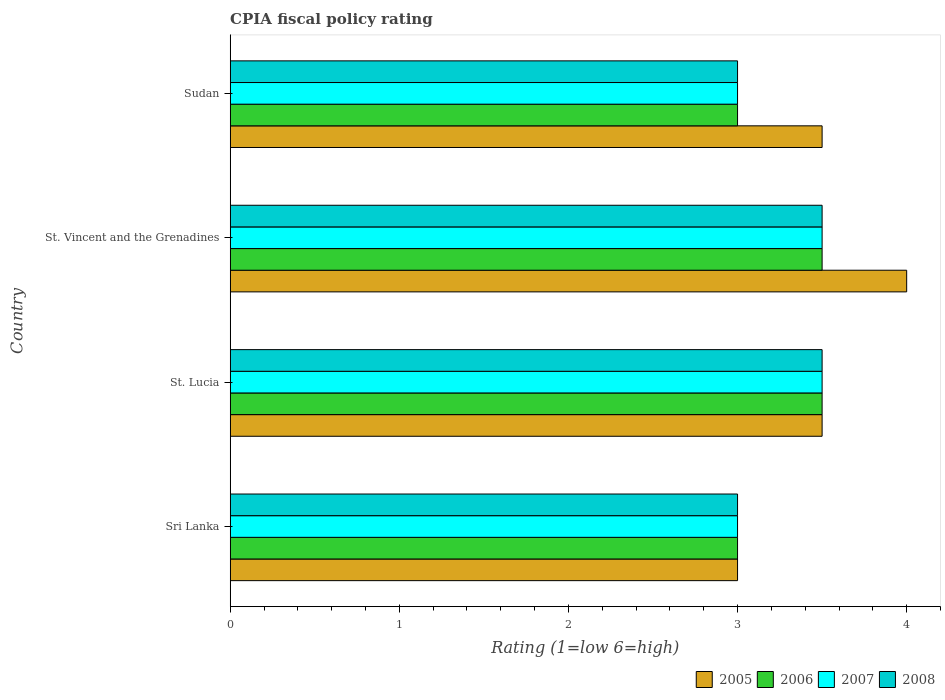How many different coloured bars are there?
Provide a short and direct response. 4. How many groups of bars are there?
Ensure brevity in your answer.  4. Are the number of bars on each tick of the Y-axis equal?
Make the answer very short. Yes. How many bars are there on the 4th tick from the bottom?
Make the answer very short. 4. What is the label of the 3rd group of bars from the top?
Provide a short and direct response. St. Lucia. In how many cases, is the number of bars for a given country not equal to the number of legend labels?
Give a very brief answer. 0. Across all countries, what is the minimum CPIA rating in 2005?
Your answer should be very brief. 3. In which country was the CPIA rating in 2006 maximum?
Provide a succinct answer. St. Lucia. In which country was the CPIA rating in 2007 minimum?
Keep it short and to the point. Sri Lanka. What is the difference between the CPIA rating in 2008 in St. Lucia and the CPIA rating in 2006 in Sri Lanka?
Provide a succinct answer. 0.5. What is the average CPIA rating in 2007 per country?
Keep it short and to the point. 3.25. What is the difference between the CPIA rating in 2007 and CPIA rating in 2006 in Sri Lanka?
Your answer should be compact. 0. In how many countries, is the CPIA rating in 2005 greater than 1.4 ?
Your response must be concise. 4. What is the ratio of the CPIA rating in 2006 in St. Lucia to that in Sudan?
Offer a very short reply. 1.17. Is the CPIA rating in 2006 in St. Vincent and the Grenadines less than that in Sudan?
Provide a succinct answer. No. Is the difference between the CPIA rating in 2007 in Sri Lanka and Sudan greater than the difference between the CPIA rating in 2006 in Sri Lanka and Sudan?
Make the answer very short. No. What is the difference between the highest and the second highest CPIA rating in 2006?
Keep it short and to the point. 0. What does the 2nd bar from the top in Sri Lanka represents?
Your answer should be compact. 2007. What does the 1st bar from the bottom in St. Vincent and the Grenadines represents?
Provide a short and direct response. 2005. Is it the case that in every country, the sum of the CPIA rating in 2007 and CPIA rating in 2006 is greater than the CPIA rating in 2005?
Offer a terse response. Yes. How many bars are there?
Give a very brief answer. 16. Are all the bars in the graph horizontal?
Provide a succinct answer. Yes. What is the difference between two consecutive major ticks on the X-axis?
Provide a succinct answer. 1. Does the graph contain any zero values?
Provide a short and direct response. No. How many legend labels are there?
Make the answer very short. 4. How are the legend labels stacked?
Give a very brief answer. Horizontal. What is the title of the graph?
Give a very brief answer. CPIA fiscal policy rating. Does "1998" appear as one of the legend labels in the graph?
Provide a succinct answer. No. What is the Rating (1=low 6=high) in 2007 in Sri Lanka?
Provide a succinct answer. 3. What is the Rating (1=low 6=high) of 2008 in Sri Lanka?
Offer a very short reply. 3. What is the Rating (1=low 6=high) in 2005 in St. Lucia?
Provide a succinct answer. 3.5. What is the Rating (1=low 6=high) in 2006 in St. Lucia?
Your answer should be very brief. 3.5. What is the Rating (1=low 6=high) of 2008 in St. Lucia?
Ensure brevity in your answer.  3.5. What is the Rating (1=low 6=high) in 2005 in St. Vincent and the Grenadines?
Make the answer very short. 4. What is the Rating (1=low 6=high) in 2006 in St. Vincent and the Grenadines?
Offer a terse response. 3.5. What is the Rating (1=low 6=high) of 2005 in Sudan?
Offer a very short reply. 3.5. What is the Rating (1=low 6=high) of 2006 in Sudan?
Offer a very short reply. 3. What is the Rating (1=low 6=high) in 2007 in Sudan?
Your answer should be very brief. 3. Across all countries, what is the maximum Rating (1=low 6=high) in 2006?
Your answer should be very brief. 3.5. Across all countries, what is the maximum Rating (1=low 6=high) of 2008?
Give a very brief answer. 3.5. Across all countries, what is the minimum Rating (1=low 6=high) in 2006?
Your answer should be compact. 3. Across all countries, what is the minimum Rating (1=low 6=high) of 2008?
Give a very brief answer. 3. What is the total Rating (1=low 6=high) in 2006 in the graph?
Your answer should be very brief. 13. What is the total Rating (1=low 6=high) in 2008 in the graph?
Offer a terse response. 13. What is the difference between the Rating (1=low 6=high) of 2006 in Sri Lanka and that in St. Lucia?
Your answer should be very brief. -0.5. What is the difference between the Rating (1=low 6=high) in 2005 in Sri Lanka and that in St. Vincent and the Grenadines?
Provide a short and direct response. -1. What is the difference between the Rating (1=low 6=high) in 2007 in Sri Lanka and that in St. Vincent and the Grenadines?
Your response must be concise. -0.5. What is the difference between the Rating (1=low 6=high) of 2005 in Sri Lanka and that in Sudan?
Give a very brief answer. -0.5. What is the difference between the Rating (1=low 6=high) in 2008 in Sri Lanka and that in Sudan?
Make the answer very short. 0. What is the difference between the Rating (1=low 6=high) in 2006 in St. Lucia and that in St. Vincent and the Grenadines?
Offer a terse response. 0. What is the difference between the Rating (1=low 6=high) in 2008 in St. Lucia and that in St. Vincent and the Grenadines?
Your answer should be compact. 0. What is the difference between the Rating (1=low 6=high) in 2007 in St. Lucia and that in Sudan?
Your answer should be very brief. 0.5. What is the difference between the Rating (1=low 6=high) in 2008 in St. Lucia and that in Sudan?
Your answer should be compact. 0.5. What is the difference between the Rating (1=low 6=high) in 2006 in St. Vincent and the Grenadines and that in Sudan?
Ensure brevity in your answer.  0.5. What is the difference between the Rating (1=low 6=high) of 2007 in St. Vincent and the Grenadines and that in Sudan?
Offer a terse response. 0.5. What is the difference between the Rating (1=low 6=high) in 2005 in Sri Lanka and the Rating (1=low 6=high) in 2007 in St. Lucia?
Your response must be concise. -0.5. What is the difference between the Rating (1=low 6=high) in 2006 in Sri Lanka and the Rating (1=low 6=high) in 2008 in St. Lucia?
Ensure brevity in your answer.  -0.5. What is the difference between the Rating (1=low 6=high) in 2007 in Sri Lanka and the Rating (1=low 6=high) in 2008 in St. Lucia?
Offer a very short reply. -0.5. What is the difference between the Rating (1=low 6=high) in 2006 in Sri Lanka and the Rating (1=low 6=high) in 2007 in St. Vincent and the Grenadines?
Give a very brief answer. -0.5. What is the difference between the Rating (1=low 6=high) of 2006 in Sri Lanka and the Rating (1=low 6=high) of 2008 in St. Vincent and the Grenadines?
Provide a succinct answer. -0.5. What is the difference between the Rating (1=low 6=high) in 2007 in Sri Lanka and the Rating (1=low 6=high) in 2008 in St. Vincent and the Grenadines?
Your answer should be very brief. -0.5. What is the difference between the Rating (1=low 6=high) of 2005 in Sri Lanka and the Rating (1=low 6=high) of 2006 in Sudan?
Give a very brief answer. 0. What is the difference between the Rating (1=low 6=high) of 2005 in Sri Lanka and the Rating (1=low 6=high) of 2007 in Sudan?
Ensure brevity in your answer.  0. What is the difference between the Rating (1=low 6=high) of 2006 in Sri Lanka and the Rating (1=low 6=high) of 2008 in Sudan?
Your response must be concise. 0. What is the difference between the Rating (1=low 6=high) of 2007 in Sri Lanka and the Rating (1=low 6=high) of 2008 in Sudan?
Your answer should be compact. 0. What is the difference between the Rating (1=low 6=high) in 2005 in St. Lucia and the Rating (1=low 6=high) in 2006 in St. Vincent and the Grenadines?
Ensure brevity in your answer.  0. What is the difference between the Rating (1=low 6=high) of 2005 in St. Lucia and the Rating (1=low 6=high) of 2007 in St. Vincent and the Grenadines?
Offer a very short reply. 0. What is the difference between the Rating (1=low 6=high) of 2006 in St. Lucia and the Rating (1=low 6=high) of 2007 in St. Vincent and the Grenadines?
Make the answer very short. 0. What is the difference between the Rating (1=low 6=high) in 2005 in St. Lucia and the Rating (1=low 6=high) in 2006 in Sudan?
Provide a succinct answer. 0.5. What is the difference between the Rating (1=low 6=high) of 2005 in St. Lucia and the Rating (1=low 6=high) of 2007 in Sudan?
Ensure brevity in your answer.  0.5. What is the difference between the Rating (1=low 6=high) in 2005 in St. Lucia and the Rating (1=low 6=high) in 2008 in Sudan?
Ensure brevity in your answer.  0.5. What is the difference between the Rating (1=low 6=high) of 2006 in St. Lucia and the Rating (1=low 6=high) of 2007 in Sudan?
Ensure brevity in your answer.  0.5. What is the difference between the Rating (1=low 6=high) of 2007 in St. Lucia and the Rating (1=low 6=high) of 2008 in Sudan?
Offer a terse response. 0.5. What is the difference between the Rating (1=low 6=high) of 2005 in St. Vincent and the Grenadines and the Rating (1=low 6=high) of 2007 in Sudan?
Offer a terse response. 1. What is the average Rating (1=low 6=high) in 2005 per country?
Give a very brief answer. 3.5. What is the average Rating (1=low 6=high) of 2006 per country?
Keep it short and to the point. 3.25. What is the average Rating (1=low 6=high) in 2007 per country?
Offer a terse response. 3.25. What is the average Rating (1=low 6=high) of 2008 per country?
Provide a short and direct response. 3.25. What is the difference between the Rating (1=low 6=high) of 2005 and Rating (1=low 6=high) of 2006 in Sri Lanka?
Give a very brief answer. 0. What is the difference between the Rating (1=low 6=high) in 2005 and Rating (1=low 6=high) in 2007 in Sri Lanka?
Your answer should be very brief. 0. What is the difference between the Rating (1=low 6=high) of 2005 and Rating (1=low 6=high) of 2008 in Sri Lanka?
Your answer should be compact. 0. What is the difference between the Rating (1=low 6=high) in 2006 and Rating (1=low 6=high) in 2007 in Sri Lanka?
Provide a succinct answer. 0. What is the difference between the Rating (1=low 6=high) in 2007 and Rating (1=low 6=high) in 2008 in Sri Lanka?
Provide a short and direct response. 0. What is the difference between the Rating (1=low 6=high) in 2005 and Rating (1=low 6=high) in 2006 in St. Lucia?
Make the answer very short. 0. What is the difference between the Rating (1=low 6=high) in 2005 and Rating (1=low 6=high) in 2007 in St. Lucia?
Keep it short and to the point. 0. What is the difference between the Rating (1=low 6=high) of 2005 and Rating (1=low 6=high) of 2008 in St. Lucia?
Give a very brief answer. 0. What is the difference between the Rating (1=low 6=high) of 2006 and Rating (1=low 6=high) of 2007 in St. Lucia?
Offer a very short reply. 0. What is the difference between the Rating (1=low 6=high) in 2006 and Rating (1=low 6=high) in 2007 in St. Vincent and the Grenadines?
Provide a succinct answer. 0. What is the difference between the Rating (1=low 6=high) of 2006 and Rating (1=low 6=high) of 2008 in St. Vincent and the Grenadines?
Ensure brevity in your answer.  0. What is the difference between the Rating (1=low 6=high) of 2007 and Rating (1=low 6=high) of 2008 in St. Vincent and the Grenadines?
Make the answer very short. 0. What is the difference between the Rating (1=low 6=high) of 2005 and Rating (1=low 6=high) of 2008 in Sudan?
Offer a very short reply. 0.5. What is the difference between the Rating (1=low 6=high) of 2006 and Rating (1=low 6=high) of 2007 in Sudan?
Ensure brevity in your answer.  0. What is the difference between the Rating (1=low 6=high) in 2007 and Rating (1=low 6=high) in 2008 in Sudan?
Your answer should be compact. 0. What is the ratio of the Rating (1=low 6=high) in 2005 in Sri Lanka to that in St. Lucia?
Your answer should be very brief. 0.86. What is the ratio of the Rating (1=low 6=high) in 2007 in Sri Lanka to that in St. Lucia?
Provide a succinct answer. 0.86. What is the ratio of the Rating (1=low 6=high) of 2007 in Sri Lanka to that in St. Vincent and the Grenadines?
Your response must be concise. 0.86. What is the ratio of the Rating (1=low 6=high) of 2008 in Sri Lanka to that in St. Vincent and the Grenadines?
Provide a short and direct response. 0.86. What is the ratio of the Rating (1=low 6=high) of 2005 in Sri Lanka to that in Sudan?
Your response must be concise. 0.86. What is the ratio of the Rating (1=low 6=high) of 2007 in Sri Lanka to that in Sudan?
Ensure brevity in your answer.  1. What is the ratio of the Rating (1=low 6=high) in 2005 in St. Lucia to that in St. Vincent and the Grenadines?
Your answer should be compact. 0.88. What is the ratio of the Rating (1=low 6=high) in 2008 in St. Lucia to that in St. Vincent and the Grenadines?
Offer a very short reply. 1. What is the ratio of the Rating (1=low 6=high) of 2005 in St. Lucia to that in Sudan?
Provide a succinct answer. 1. What is the ratio of the Rating (1=low 6=high) in 2006 in St. Lucia to that in Sudan?
Provide a short and direct response. 1.17. What is the ratio of the Rating (1=low 6=high) in 2007 in St. Lucia to that in Sudan?
Your answer should be compact. 1.17. What is the ratio of the Rating (1=low 6=high) of 2008 in St. Lucia to that in Sudan?
Ensure brevity in your answer.  1.17. What is the ratio of the Rating (1=low 6=high) in 2006 in St. Vincent and the Grenadines to that in Sudan?
Ensure brevity in your answer.  1.17. What is the ratio of the Rating (1=low 6=high) of 2007 in St. Vincent and the Grenadines to that in Sudan?
Ensure brevity in your answer.  1.17. What is the difference between the highest and the second highest Rating (1=low 6=high) in 2005?
Your answer should be compact. 0.5. What is the difference between the highest and the second highest Rating (1=low 6=high) of 2006?
Keep it short and to the point. 0. What is the difference between the highest and the second highest Rating (1=low 6=high) in 2008?
Your answer should be compact. 0. What is the difference between the highest and the lowest Rating (1=low 6=high) of 2007?
Make the answer very short. 0.5. 